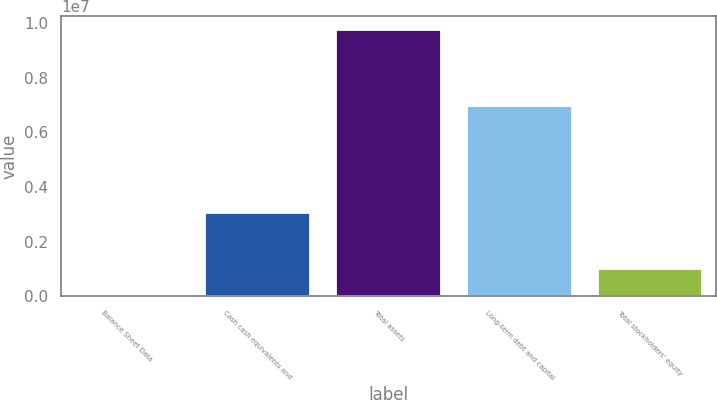<chart> <loc_0><loc_0><loc_500><loc_500><bar_chart><fcel>Balance Sheet Data<fcel>Cash cash equivalents and<fcel>Total assets<fcel>Long-term debt and capital<fcel>Total stockholders' equity<nl><fcel>2006<fcel>3.03257e+06<fcel>9.7687e+06<fcel>6.96732e+06<fcel>978675<nl></chart> 